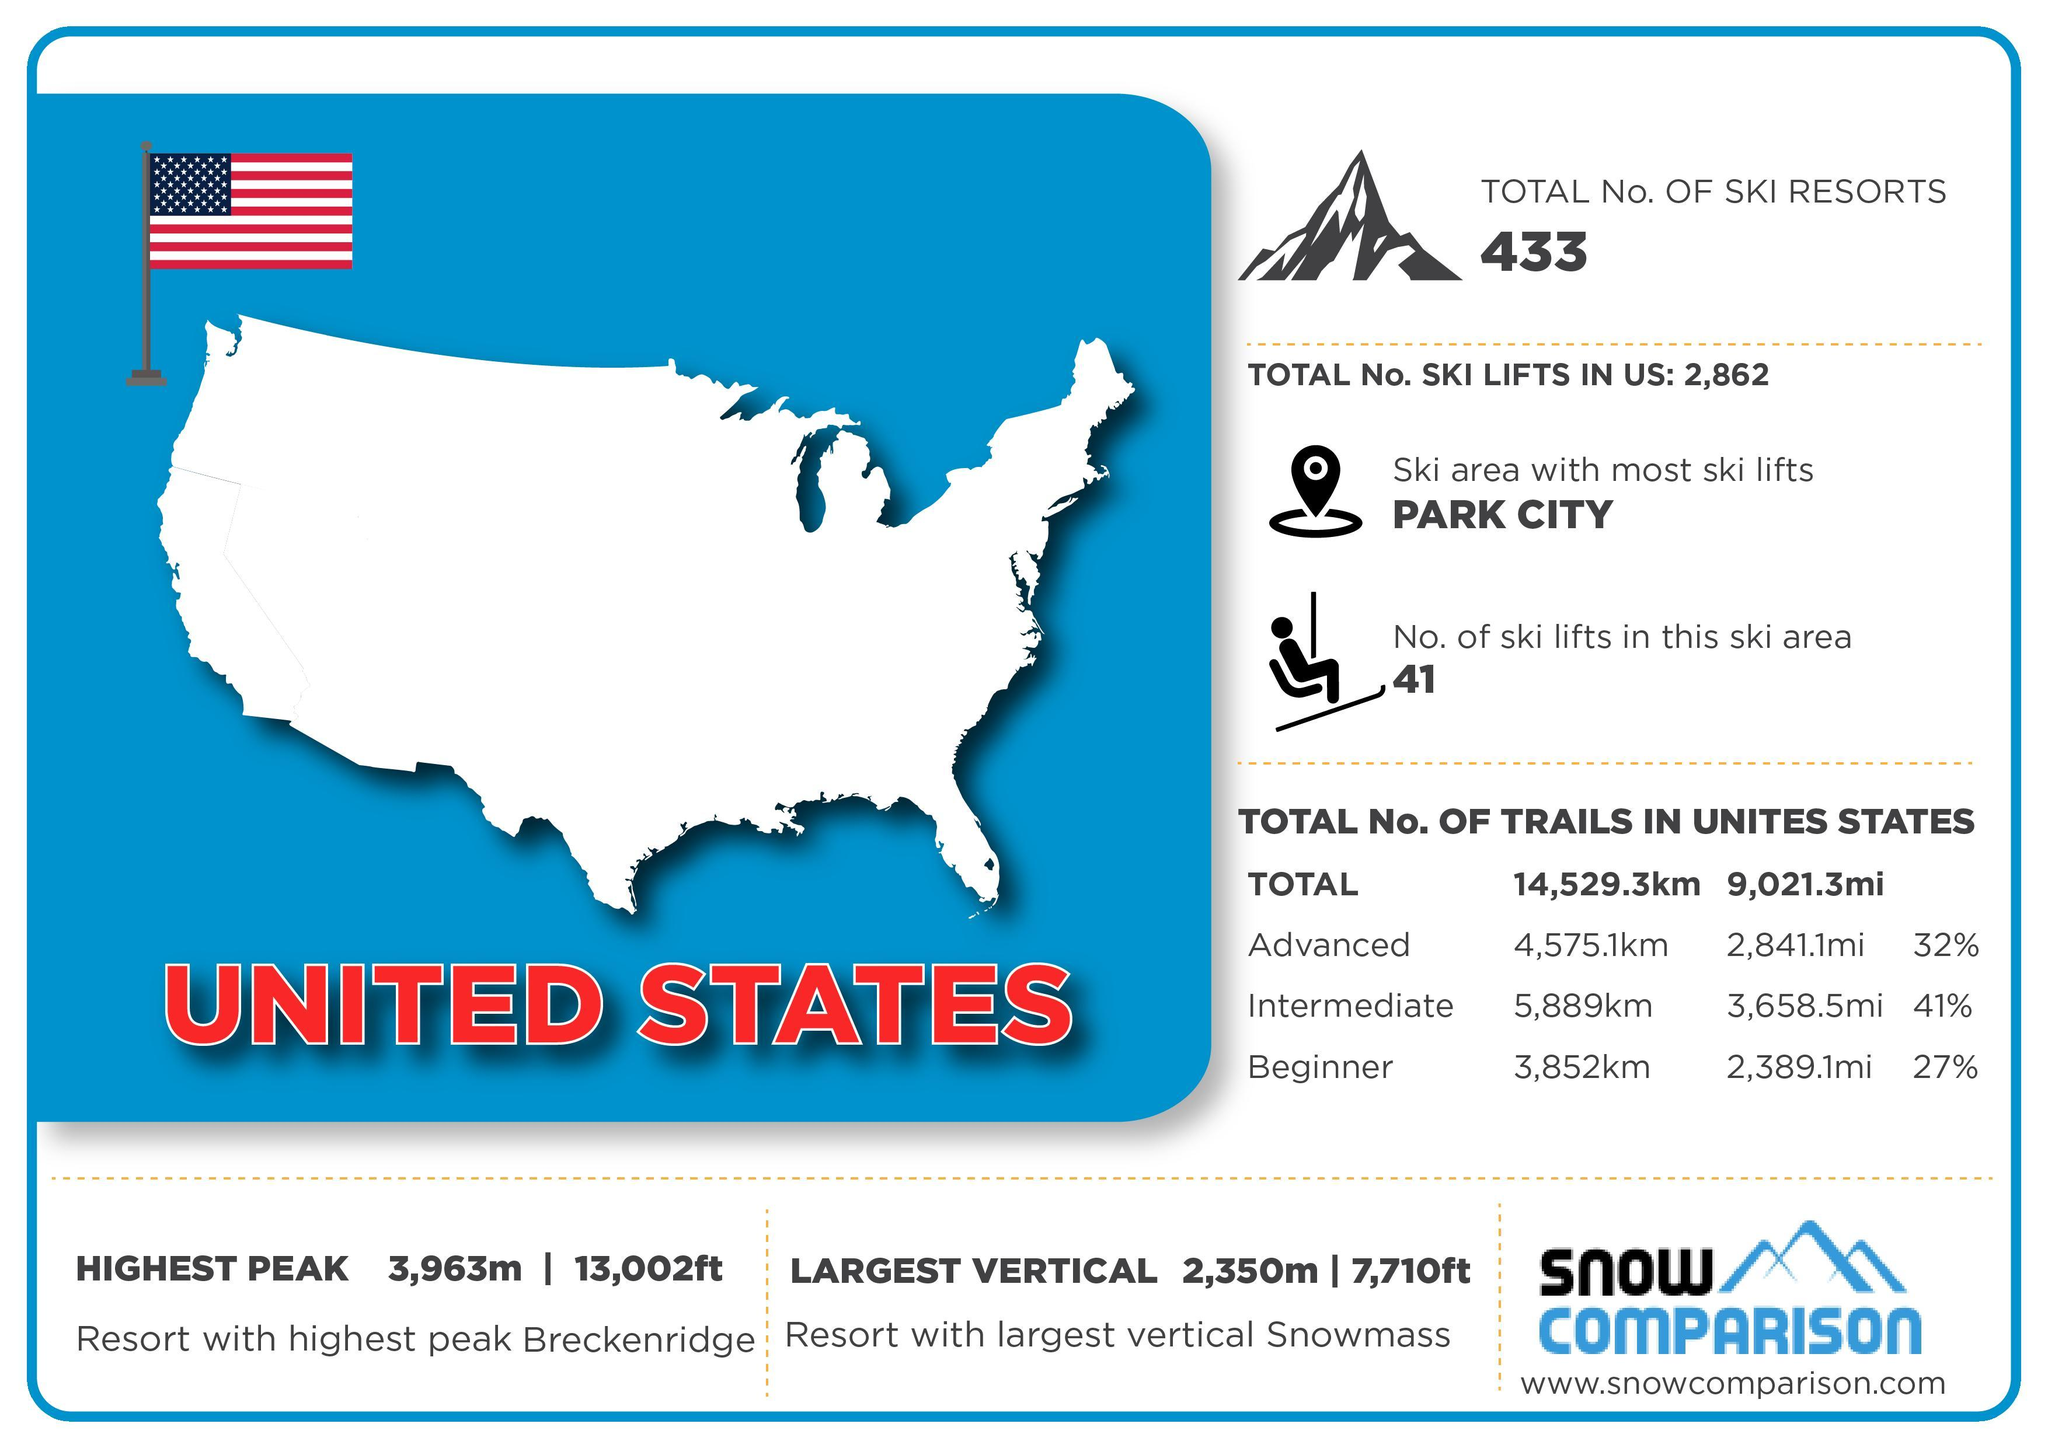What is the difference in length  between the Intermediate and Beginner trails in kilometers?
Answer the question with a short phrase. 2037 km What is the difference in length between advanced and beginner trails in miles ? 452 mi Which is longest trail advanced, intermediate or beginner ? Intermediate What is the total percentage of Advanced, Intermediate and Beginner trails in the US ? 100% 